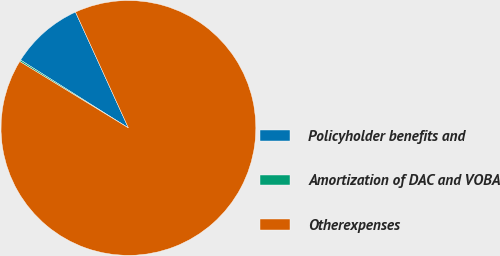Convert chart. <chart><loc_0><loc_0><loc_500><loc_500><pie_chart><fcel>Policyholder benefits and<fcel>Amortization of DAC and VOBA<fcel>Otherexpenses<nl><fcel>9.24%<fcel>0.2%<fcel>90.56%<nl></chart> 